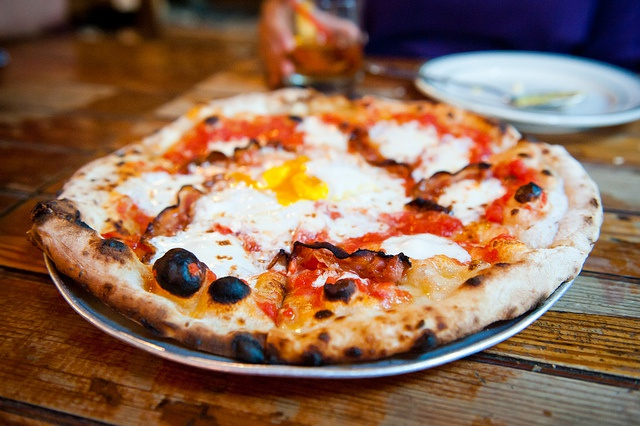Describe the objects in this image and their specific colors. I can see dining table in maroon, lightgray, gray, black, and brown tones, pizza in gray, lightgray, tan, and red tones, pizza in gray, lightgray, tan, and red tones, cup in gray, maroon, and brown tones, and fork in gray, lightblue, and darkgray tones in this image. 